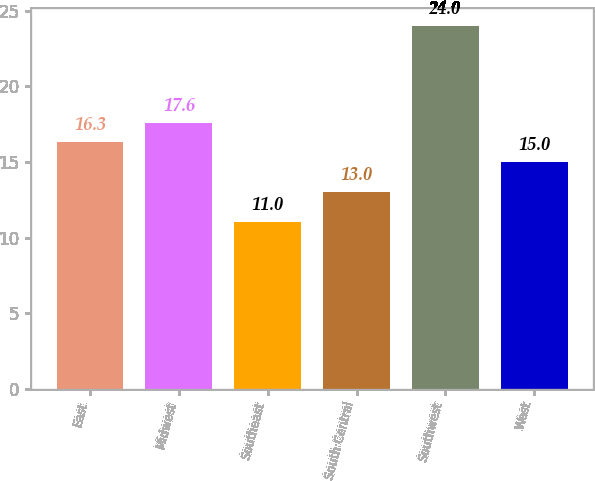Convert chart to OTSL. <chart><loc_0><loc_0><loc_500><loc_500><bar_chart><fcel>East<fcel>Midwest<fcel>Southeast<fcel>South Central<fcel>Southwest<fcel>West<nl><fcel>16.3<fcel>17.6<fcel>11<fcel>13<fcel>24<fcel>15<nl></chart> 